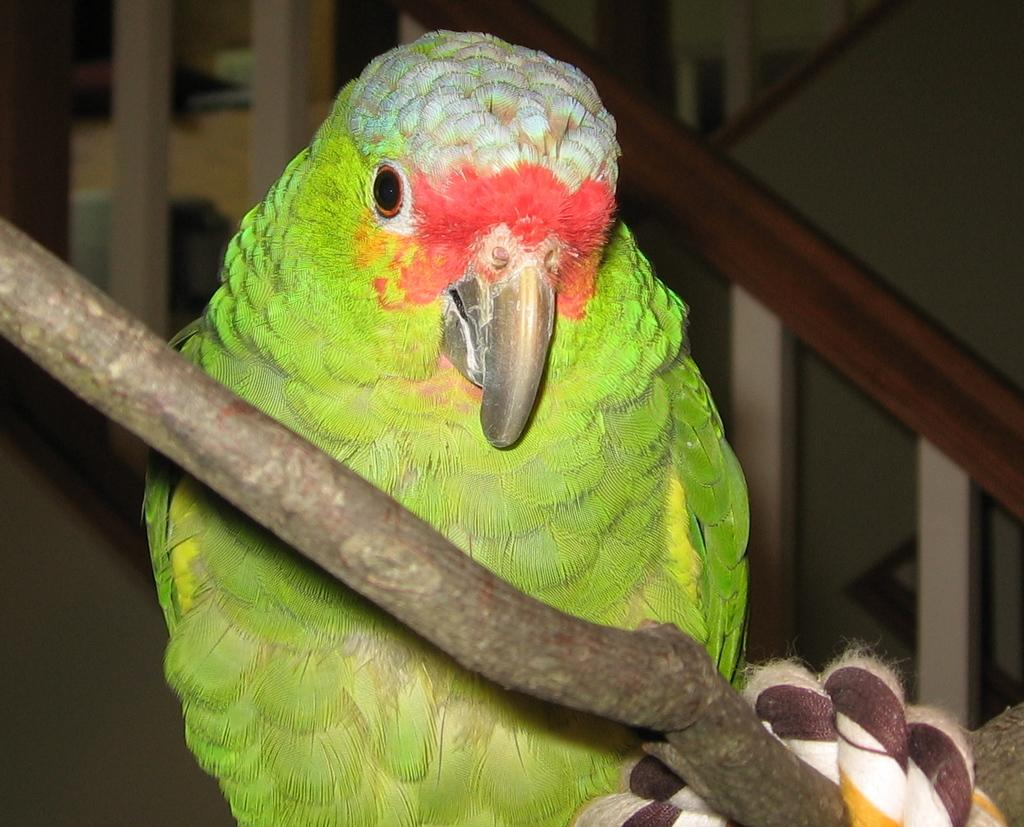What is the main object in the image? There is a stick in the image. What type of material is the spiral object made of? There is a spiral cloth in the image. What type of animal can be seen in the image? There is a bird in the image. What can be seen in the background of the image? There is a fence and other objects visible in the background of the image. What time of day is it in the image, and is there any popcorn present? The time of day cannot be determined from the image, and there is no popcorn present. Is there an arch visible in the image? There is no arch visible in the image. 